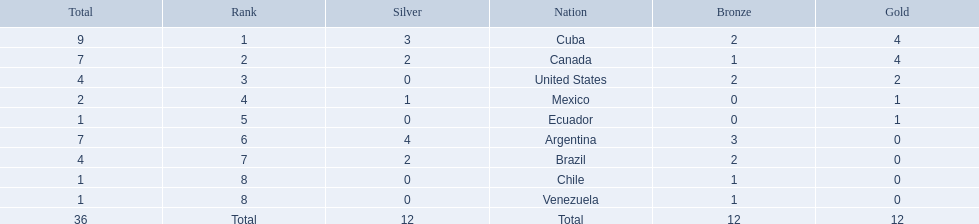What were all of the nations involved in the canoeing at the 2011 pan american games? Cuba, Canada, United States, Mexico, Ecuador, Argentina, Brazil, Chile, Venezuela, Total. Of these, which had a numbered rank? Cuba, Canada, United States, Mexico, Ecuador, Argentina, Brazil, Chile, Venezuela. From these, which had the highest number of bronze? Argentina. 